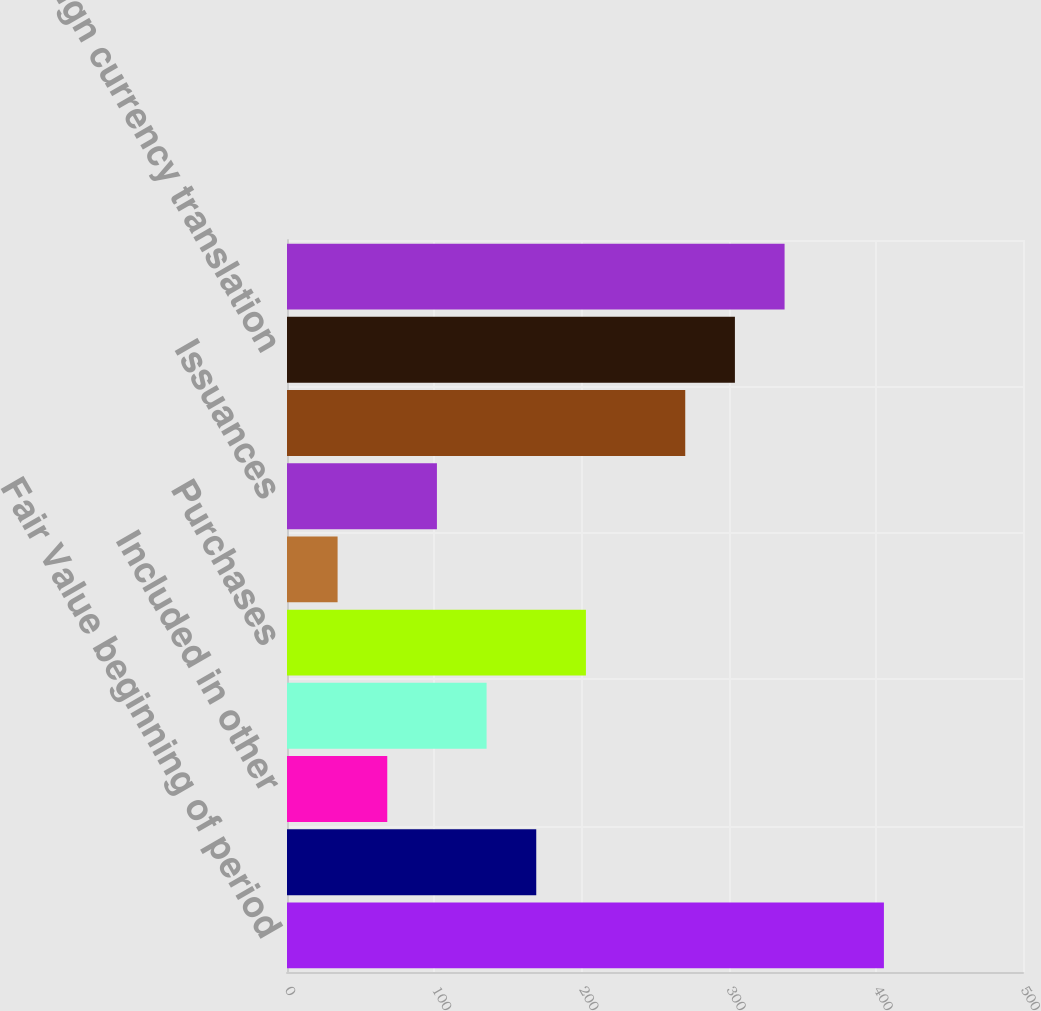Convert chart. <chart><loc_0><loc_0><loc_500><loc_500><bar_chart><fcel>Fair Value beginning of period<fcel>Realized investment gains<fcel>Included in other<fcel>Net investment income<fcel>Purchases<fcel>Sales<fcel>Issuances<fcel>Settlements<fcel>Foreign currency translation<fcel>Other(1)<nl><fcel>405.51<fcel>169.33<fcel>68.11<fcel>135.59<fcel>203.07<fcel>34.37<fcel>101.85<fcel>270.55<fcel>304.29<fcel>338.03<nl></chart> 